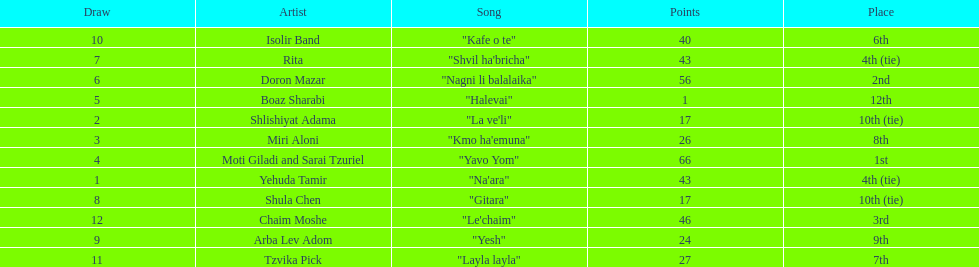What is the name of the first song listed on this chart? "Na'ara". 